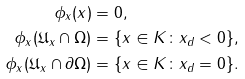Convert formula to latex. <formula><loc_0><loc_0><loc_500><loc_500>\phi _ { x } ( x ) & = 0 , \\ \phi _ { x } ( \mathfrak U _ { x } \cap \Omega ) & = \{ x \in K \colon x _ { d } < 0 \} , \\ \phi _ { x } ( \mathfrak U _ { x } \cap \partial \Omega ) & = \{ x \in K \colon x _ { d } = 0 \} .</formula> 